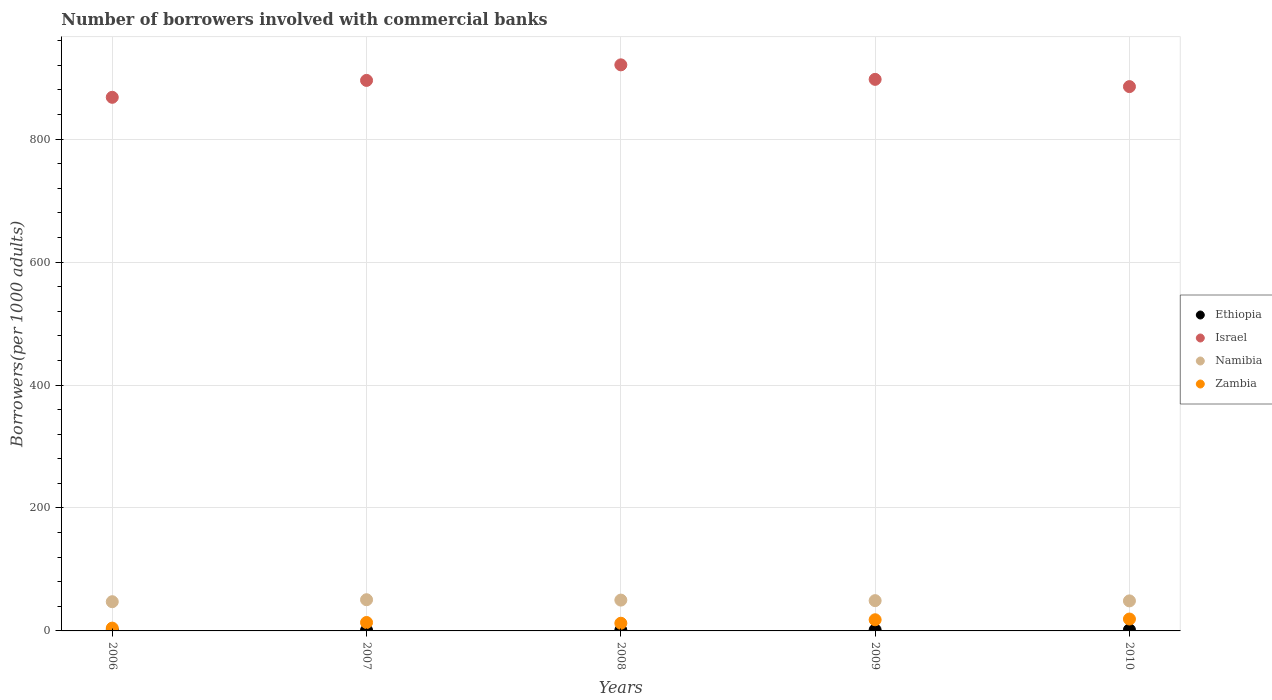How many different coloured dotlines are there?
Offer a very short reply. 4. Is the number of dotlines equal to the number of legend labels?
Keep it short and to the point. Yes. What is the number of borrowers involved with commercial banks in Namibia in 2010?
Your response must be concise. 48.85. Across all years, what is the maximum number of borrowers involved with commercial banks in Namibia?
Make the answer very short. 50.74. Across all years, what is the minimum number of borrowers involved with commercial banks in Namibia?
Keep it short and to the point. 47.51. In which year was the number of borrowers involved with commercial banks in Zambia maximum?
Make the answer very short. 2010. In which year was the number of borrowers involved with commercial banks in Namibia minimum?
Ensure brevity in your answer.  2006. What is the total number of borrowers involved with commercial banks in Namibia in the graph?
Keep it short and to the point. 246.49. What is the difference between the number of borrowers involved with commercial banks in Zambia in 2007 and that in 2010?
Make the answer very short. -5.62. What is the difference between the number of borrowers involved with commercial banks in Israel in 2006 and the number of borrowers involved with commercial banks in Ethiopia in 2007?
Give a very brief answer. 866.91. What is the average number of borrowers involved with commercial banks in Zambia per year?
Offer a very short reply. 13.64. In the year 2009, what is the difference between the number of borrowers involved with commercial banks in Namibia and number of borrowers involved with commercial banks in Ethiopia?
Provide a short and direct response. 47.6. What is the ratio of the number of borrowers involved with commercial banks in Zambia in 2007 to that in 2010?
Your response must be concise. 0.71. Is the number of borrowers involved with commercial banks in Israel in 2006 less than that in 2010?
Give a very brief answer. Yes. What is the difference between the highest and the second highest number of borrowers involved with commercial banks in Israel?
Provide a short and direct response. 23.61. What is the difference between the highest and the lowest number of borrowers involved with commercial banks in Ethiopia?
Ensure brevity in your answer.  0.73. In how many years, is the number of borrowers involved with commercial banks in Israel greater than the average number of borrowers involved with commercial banks in Israel taken over all years?
Offer a very short reply. 3. Is the sum of the number of borrowers involved with commercial banks in Namibia in 2007 and 2010 greater than the maximum number of borrowers involved with commercial banks in Zambia across all years?
Offer a very short reply. Yes. Is it the case that in every year, the sum of the number of borrowers involved with commercial banks in Israel and number of borrowers involved with commercial banks in Namibia  is greater than the sum of number of borrowers involved with commercial banks in Zambia and number of borrowers involved with commercial banks in Ethiopia?
Your answer should be compact. Yes. Is it the case that in every year, the sum of the number of borrowers involved with commercial banks in Zambia and number of borrowers involved with commercial banks in Israel  is greater than the number of borrowers involved with commercial banks in Ethiopia?
Your answer should be very brief. Yes. Is the number of borrowers involved with commercial banks in Israel strictly greater than the number of borrowers involved with commercial banks in Namibia over the years?
Give a very brief answer. Yes. Is the number of borrowers involved with commercial banks in Namibia strictly less than the number of borrowers involved with commercial banks in Israel over the years?
Your response must be concise. Yes. How many dotlines are there?
Give a very brief answer. 4. How many years are there in the graph?
Provide a succinct answer. 5. What is the difference between two consecutive major ticks on the Y-axis?
Offer a terse response. 200. Are the values on the major ticks of Y-axis written in scientific E-notation?
Provide a short and direct response. No. Where does the legend appear in the graph?
Keep it short and to the point. Center right. What is the title of the graph?
Provide a succinct answer. Number of borrowers involved with commercial banks. What is the label or title of the X-axis?
Give a very brief answer. Years. What is the label or title of the Y-axis?
Offer a terse response. Borrowers(per 1000 adults). What is the Borrowers(per 1000 adults) in Ethiopia in 2006?
Make the answer very short. 1.21. What is the Borrowers(per 1000 adults) in Israel in 2006?
Your answer should be very brief. 867.97. What is the Borrowers(per 1000 adults) in Namibia in 2006?
Offer a very short reply. 47.51. What is the Borrowers(per 1000 adults) of Zambia in 2006?
Give a very brief answer. 4.56. What is the Borrowers(per 1000 adults) of Ethiopia in 2007?
Your answer should be very brief. 1.05. What is the Borrowers(per 1000 adults) in Israel in 2007?
Keep it short and to the point. 895.46. What is the Borrowers(per 1000 adults) in Namibia in 2007?
Your answer should be compact. 50.74. What is the Borrowers(per 1000 adults) in Zambia in 2007?
Offer a very short reply. 13.71. What is the Borrowers(per 1000 adults) in Ethiopia in 2008?
Make the answer very short. 1.18. What is the Borrowers(per 1000 adults) of Israel in 2008?
Make the answer very short. 920.77. What is the Borrowers(per 1000 adults) of Namibia in 2008?
Keep it short and to the point. 50.14. What is the Borrowers(per 1000 adults) in Zambia in 2008?
Your answer should be very brief. 12.48. What is the Borrowers(per 1000 adults) in Ethiopia in 2009?
Provide a succinct answer. 1.65. What is the Borrowers(per 1000 adults) of Israel in 2009?
Your response must be concise. 897.16. What is the Borrowers(per 1000 adults) in Namibia in 2009?
Offer a very short reply. 49.25. What is the Borrowers(per 1000 adults) in Zambia in 2009?
Your response must be concise. 18.15. What is the Borrowers(per 1000 adults) of Ethiopia in 2010?
Make the answer very short. 1.78. What is the Borrowers(per 1000 adults) of Israel in 2010?
Provide a short and direct response. 885.37. What is the Borrowers(per 1000 adults) of Namibia in 2010?
Your answer should be very brief. 48.85. What is the Borrowers(per 1000 adults) of Zambia in 2010?
Provide a succinct answer. 19.32. Across all years, what is the maximum Borrowers(per 1000 adults) in Ethiopia?
Ensure brevity in your answer.  1.78. Across all years, what is the maximum Borrowers(per 1000 adults) in Israel?
Your answer should be compact. 920.77. Across all years, what is the maximum Borrowers(per 1000 adults) of Namibia?
Provide a succinct answer. 50.74. Across all years, what is the maximum Borrowers(per 1000 adults) in Zambia?
Give a very brief answer. 19.32. Across all years, what is the minimum Borrowers(per 1000 adults) in Ethiopia?
Offer a terse response. 1.05. Across all years, what is the minimum Borrowers(per 1000 adults) in Israel?
Your answer should be compact. 867.97. Across all years, what is the minimum Borrowers(per 1000 adults) in Namibia?
Keep it short and to the point. 47.51. Across all years, what is the minimum Borrowers(per 1000 adults) of Zambia?
Provide a short and direct response. 4.56. What is the total Borrowers(per 1000 adults) of Ethiopia in the graph?
Offer a terse response. 6.88. What is the total Borrowers(per 1000 adults) of Israel in the graph?
Your response must be concise. 4466.73. What is the total Borrowers(per 1000 adults) in Namibia in the graph?
Keep it short and to the point. 246.49. What is the total Borrowers(per 1000 adults) in Zambia in the graph?
Ensure brevity in your answer.  68.22. What is the difference between the Borrowers(per 1000 adults) in Ethiopia in 2006 and that in 2007?
Provide a succinct answer. 0.15. What is the difference between the Borrowers(per 1000 adults) in Israel in 2006 and that in 2007?
Give a very brief answer. -27.5. What is the difference between the Borrowers(per 1000 adults) of Namibia in 2006 and that in 2007?
Your answer should be very brief. -3.23. What is the difference between the Borrowers(per 1000 adults) in Zambia in 2006 and that in 2007?
Your answer should be very brief. -9.14. What is the difference between the Borrowers(per 1000 adults) of Ethiopia in 2006 and that in 2008?
Your answer should be compact. 0.02. What is the difference between the Borrowers(per 1000 adults) of Israel in 2006 and that in 2008?
Provide a succinct answer. -52.8. What is the difference between the Borrowers(per 1000 adults) of Namibia in 2006 and that in 2008?
Your answer should be compact. -2.63. What is the difference between the Borrowers(per 1000 adults) in Zambia in 2006 and that in 2008?
Offer a very short reply. -7.92. What is the difference between the Borrowers(per 1000 adults) in Ethiopia in 2006 and that in 2009?
Keep it short and to the point. -0.45. What is the difference between the Borrowers(per 1000 adults) in Israel in 2006 and that in 2009?
Keep it short and to the point. -29.19. What is the difference between the Borrowers(per 1000 adults) in Namibia in 2006 and that in 2009?
Offer a very short reply. -1.74. What is the difference between the Borrowers(per 1000 adults) in Zambia in 2006 and that in 2009?
Provide a short and direct response. -13.59. What is the difference between the Borrowers(per 1000 adults) of Ethiopia in 2006 and that in 2010?
Give a very brief answer. -0.58. What is the difference between the Borrowers(per 1000 adults) of Israel in 2006 and that in 2010?
Keep it short and to the point. -17.4. What is the difference between the Borrowers(per 1000 adults) of Namibia in 2006 and that in 2010?
Keep it short and to the point. -1.34. What is the difference between the Borrowers(per 1000 adults) of Zambia in 2006 and that in 2010?
Your answer should be very brief. -14.76. What is the difference between the Borrowers(per 1000 adults) in Ethiopia in 2007 and that in 2008?
Keep it short and to the point. -0.13. What is the difference between the Borrowers(per 1000 adults) in Israel in 2007 and that in 2008?
Make the answer very short. -25.3. What is the difference between the Borrowers(per 1000 adults) of Namibia in 2007 and that in 2008?
Your answer should be very brief. 0.6. What is the difference between the Borrowers(per 1000 adults) in Zambia in 2007 and that in 2008?
Offer a terse response. 1.22. What is the difference between the Borrowers(per 1000 adults) in Ethiopia in 2007 and that in 2009?
Give a very brief answer. -0.6. What is the difference between the Borrowers(per 1000 adults) of Israel in 2007 and that in 2009?
Offer a terse response. -1.7. What is the difference between the Borrowers(per 1000 adults) in Namibia in 2007 and that in 2009?
Your response must be concise. 1.49. What is the difference between the Borrowers(per 1000 adults) of Zambia in 2007 and that in 2009?
Your response must be concise. -4.45. What is the difference between the Borrowers(per 1000 adults) in Ethiopia in 2007 and that in 2010?
Your response must be concise. -0.73. What is the difference between the Borrowers(per 1000 adults) in Israel in 2007 and that in 2010?
Offer a terse response. 10.09. What is the difference between the Borrowers(per 1000 adults) of Namibia in 2007 and that in 2010?
Offer a terse response. 1.89. What is the difference between the Borrowers(per 1000 adults) in Zambia in 2007 and that in 2010?
Keep it short and to the point. -5.62. What is the difference between the Borrowers(per 1000 adults) of Ethiopia in 2008 and that in 2009?
Your answer should be compact. -0.47. What is the difference between the Borrowers(per 1000 adults) of Israel in 2008 and that in 2009?
Offer a very short reply. 23.61. What is the difference between the Borrowers(per 1000 adults) in Namibia in 2008 and that in 2009?
Keep it short and to the point. 0.89. What is the difference between the Borrowers(per 1000 adults) in Zambia in 2008 and that in 2009?
Offer a terse response. -5.67. What is the difference between the Borrowers(per 1000 adults) of Ethiopia in 2008 and that in 2010?
Ensure brevity in your answer.  -0.6. What is the difference between the Borrowers(per 1000 adults) of Israel in 2008 and that in 2010?
Make the answer very short. 35.4. What is the difference between the Borrowers(per 1000 adults) in Namibia in 2008 and that in 2010?
Make the answer very short. 1.29. What is the difference between the Borrowers(per 1000 adults) in Zambia in 2008 and that in 2010?
Your answer should be compact. -6.84. What is the difference between the Borrowers(per 1000 adults) in Ethiopia in 2009 and that in 2010?
Your answer should be very brief. -0.13. What is the difference between the Borrowers(per 1000 adults) of Israel in 2009 and that in 2010?
Give a very brief answer. 11.79. What is the difference between the Borrowers(per 1000 adults) of Namibia in 2009 and that in 2010?
Offer a terse response. 0.4. What is the difference between the Borrowers(per 1000 adults) in Zambia in 2009 and that in 2010?
Offer a terse response. -1.17. What is the difference between the Borrowers(per 1000 adults) of Ethiopia in 2006 and the Borrowers(per 1000 adults) of Israel in 2007?
Give a very brief answer. -894.26. What is the difference between the Borrowers(per 1000 adults) in Ethiopia in 2006 and the Borrowers(per 1000 adults) in Namibia in 2007?
Keep it short and to the point. -49.53. What is the difference between the Borrowers(per 1000 adults) in Ethiopia in 2006 and the Borrowers(per 1000 adults) in Zambia in 2007?
Your response must be concise. -12.5. What is the difference between the Borrowers(per 1000 adults) in Israel in 2006 and the Borrowers(per 1000 adults) in Namibia in 2007?
Your answer should be very brief. 817.23. What is the difference between the Borrowers(per 1000 adults) in Israel in 2006 and the Borrowers(per 1000 adults) in Zambia in 2007?
Provide a short and direct response. 854.26. What is the difference between the Borrowers(per 1000 adults) of Namibia in 2006 and the Borrowers(per 1000 adults) of Zambia in 2007?
Provide a succinct answer. 33.8. What is the difference between the Borrowers(per 1000 adults) in Ethiopia in 2006 and the Borrowers(per 1000 adults) in Israel in 2008?
Give a very brief answer. -919.56. What is the difference between the Borrowers(per 1000 adults) in Ethiopia in 2006 and the Borrowers(per 1000 adults) in Namibia in 2008?
Offer a very short reply. -48.93. What is the difference between the Borrowers(per 1000 adults) of Ethiopia in 2006 and the Borrowers(per 1000 adults) of Zambia in 2008?
Give a very brief answer. -11.28. What is the difference between the Borrowers(per 1000 adults) of Israel in 2006 and the Borrowers(per 1000 adults) of Namibia in 2008?
Ensure brevity in your answer.  817.83. What is the difference between the Borrowers(per 1000 adults) of Israel in 2006 and the Borrowers(per 1000 adults) of Zambia in 2008?
Your response must be concise. 855.48. What is the difference between the Borrowers(per 1000 adults) in Namibia in 2006 and the Borrowers(per 1000 adults) in Zambia in 2008?
Offer a terse response. 35.03. What is the difference between the Borrowers(per 1000 adults) of Ethiopia in 2006 and the Borrowers(per 1000 adults) of Israel in 2009?
Provide a short and direct response. -895.95. What is the difference between the Borrowers(per 1000 adults) of Ethiopia in 2006 and the Borrowers(per 1000 adults) of Namibia in 2009?
Your answer should be very brief. -48.04. What is the difference between the Borrowers(per 1000 adults) of Ethiopia in 2006 and the Borrowers(per 1000 adults) of Zambia in 2009?
Provide a succinct answer. -16.95. What is the difference between the Borrowers(per 1000 adults) in Israel in 2006 and the Borrowers(per 1000 adults) in Namibia in 2009?
Give a very brief answer. 818.72. What is the difference between the Borrowers(per 1000 adults) of Israel in 2006 and the Borrowers(per 1000 adults) of Zambia in 2009?
Your answer should be very brief. 849.81. What is the difference between the Borrowers(per 1000 adults) in Namibia in 2006 and the Borrowers(per 1000 adults) in Zambia in 2009?
Your response must be concise. 29.36. What is the difference between the Borrowers(per 1000 adults) in Ethiopia in 2006 and the Borrowers(per 1000 adults) in Israel in 2010?
Keep it short and to the point. -884.16. What is the difference between the Borrowers(per 1000 adults) in Ethiopia in 2006 and the Borrowers(per 1000 adults) in Namibia in 2010?
Offer a terse response. -47.64. What is the difference between the Borrowers(per 1000 adults) in Ethiopia in 2006 and the Borrowers(per 1000 adults) in Zambia in 2010?
Keep it short and to the point. -18.12. What is the difference between the Borrowers(per 1000 adults) in Israel in 2006 and the Borrowers(per 1000 adults) in Namibia in 2010?
Give a very brief answer. 819.12. What is the difference between the Borrowers(per 1000 adults) in Israel in 2006 and the Borrowers(per 1000 adults) in Zambia in 2010?
Provide a short and direct response. 848.64. What is the difference between the Borrowers(per 1000 adults) of Namibia in 2006 and the Borrowers(per 1000 adults) of Zambia in 2010?
Ensure brevity in your answer.  28.19. What is the difference between the Borrowers(per 1000 adults) of Ethiopia in 2007 and the Borrowers(per 1000 adults) of Israel in 2008?
Keep it short and to the point. -919.72. What is the difference between the Borrowers(per 1000 adults) of Ethiopia in 2007 and the Borrowers(per 1000 adults) of Namibia in 2008?
Provide a succinct answer. -49.09. What is the difference between the Borrowers(per 1000 adults) in Ethiopia in 2007 and the Borrowers(per 1000 adults) in Zambia in 2008?
Provide a succinct answer. -11.43. What is the difference between the Borrowers(per 1000 adults) in Israel in 2007 and the Borrowers(per 1000 adults) in Namibia in 2008?
Offer a very short reply. 845.32. What is the difference between the Borrowers(per 1000 adults) of Israel in 2007 and the Borrowers(per 1000 adults) of Zambia in 2008?
Give a very brief answer. 882.98. What is the difference between the Borrowers(per 1000 adults) in Namibia in 2007 and the Borrowers(per 1000 adults) in Zambia in 2008?
Your answer should be very brief. 38.26. What is the difference between the Borrowers(per 1000 adults) in Ethiopia in 2007 and the Borrowers(per 1000 adults) in Israel in 2009?
Your answer should be very brief. -896.11. What is the difference between the Borrowers(per 1000 adults) in Ethiopia in 2007 and the Borrowers(per 1000 adults) in Namibia in 2009?
Your answer should be very brief. -48.2. What is the difference between the Borrowers(per 1000 adults) in Ethiopia in 2007 and the Borrowers(per 1000 adults) in Zambia in 2009?
Make the answer very short. -17.1. What is the difference between the Borrowers(per 1000 adults) in Israel in 2007 and the Borrowers(per 1000 adults) in Namibia in 2009?
Offer a very short reply. 846.21. What is the difference between the Borrowers(per 1000 adults) in Israel in 2007 and the Borrowers(per 1000 adults) in Zambia in 2009?
Offer a very short reply. 877.31. What is the difference between the Borrowers(per 1000 adults) in Namibia in 2007 and the Borrowers(per 1000 adults) in Zambia in 2009?
Your answer should be compact. 32.59. What is the difference between the Borrowers(per 1000 adults) of Ethiopia in 2007 and the Borrowers(per 1000 adults) of Israel in 2010?
Provide a succinct answer. -884.32. What is the difference between the Borrowers(per 1000 adults) of Ethiopia in 2007 and the Borrowers(per 1000 adults) of Namibia in 2010?
Ensure brevity in your answer.  -47.79. What is the difference between the Borrowers(per 1000 adults) of Ethiopia in 2007 and the Borrowers(per 1000 adults) of Zambia in 2010?
Provide a succinct answer. -18.27. What is the difference between the Borrowers(per 1000 adults) of Israel in 2007 and the Borrowers(per 1000 adults) of Namibia in 2010?
Ensure brevity in your answer.  846.62. What is the difference between the Borrowers(per 1000 adults) of Israel in 2007 and the Borrowers(per 1000 adults) of Zambia in 2010?
Your response must be concise. 876.14. What is the difference between the Borrowers(per 1000 adults) in Namibia in 2007 and the Borrowers(per 1000 adults) in Zambia in 2010?
Your answer should be very brief. 31.42. What is the difference between the Borrowers(per 1000 adults) in Ethiopia in 2008 and the Borrowers(per 1000 adults) in Israel in 2009?
Your answer should be very brief. -895.98. What is the difference between the Borrowers(per 1000 adults) of Ethiopia in 2008 and the Borrowers(per 1000 adults) of Namibia in 2009?
Ensure brevity in your answer.  -48.07. What is the difference between the Borrowers(per 1000 adults) of Ethiopia in 2008 and the Borrowers(per 1000 adults) of Zambia in 2009?
Keep it short and to the point. -16.97. What is the difference between the Borrowers(per 1000 adults) of Israel in 2008 and the Borrowers(per 1000 adults) of Namibia in 2009?
Make the answer very short. 871.52. What is the difference between the Borrowers(per 1000 adults) in Israel in 2008 and the Borrowers(per 1000 adults) in Zambia in 2009?
Your answer should be compact. 902.62. What is the difference between the Borrowers(per 1000 adults) in Namibia in 2008 and the Borrowers(per 1000 adults) in Zambia in 2009?
Your response must be concise. 31.99. What is the difference between the Borrowers(per 1000 adults) in Ethiopia in 2008 and the Borrowers(per 1000 adults) in Israel in 2010?
Make the answer very short. -884.19. What is the difference between the Borrowers(per 1000 adults) in Ethiopia in 2008 and the Borrowers(per 1000 adults) in Namibia in 2010?
Your response must be concise. -47.67. What is the difference between the Borrowers(per 1000 adults) of Ethiopia in 2008 and the Borrowers(per 1000 adults) of Zambia in 2010?
Offer a terse response. -18.14. What is the difference between the Borrowers(per 1000 adults) of Israel in 2008 and the Borrowers(per 1000 adults) of Namibia in 2010?
Provide a succinct answer. 871.92. What is the difference between the Borrowers(per 1000 adults) in Israel in 2008 and the Borrowers(per 1000 adults) in Zambia in 2010?
Provide a succinct answer. 901.45. What is the difference between the Borrowers(per 1000 adults) of Namibia in 2008 and the Borrowers(per 1000 adults) of Zambia in 2010?
Provide a short and direct response. 30.82. What is the difference between the Borrowers(per 1000 adults) in Ethiopia in 2009 and the Borrowers(per 1000 adults) in Israel in 2010?
Ensure brevity in your answer.  -883.72. What is the difference between the Borrowers(per 1000 adults) in Ethiopia in 2009 and the Borrowers(per 1000 adults) in Namibia in 2010?
Your answer should be compact. -47.2. What is the difference between the Borrowers(per 1000 adults) in Ethiopia in 2009 and the Borrowers(per 1000 adults) in Zambia in 2010?
Your response must be concise. -17.67. What is the difference between the Borrowers(per 1000 adults) of Israel in 2009 and the Borrowers(per 1000 adults) of Namibia in 2010?
Ensure brevity in your answer.  848.31. What is the difference between the Borrowers(per 1000 adults) in Israel in 2009 and the Borrowers(per 1000 adults) in Zambia in 2010?
Your answer should be compact. 877.84. What is the difference between the Borrowers(per 1000 adults) of Namibia in 2009 and the Borrowers(per 1000 adults) of Zambia in 2010?
Offer a terse response. 29.93. What is the average Borrowers(per 1000 adults) of Ethiopia per year?
Ensure brevity in your answer.  1.38. What is the average Borrowers(per 1000 adults) in Israel per year?
Provide a succinct answer. 893.35. What is the average Borrowers(per 1000 adults) of Namibia per year?
Offer a terse response. 49.3. What is the average Borrowers(per 1000 adults) of Zambia per year?
Provide a short and direct response. 13.64. In the year 2006, what is the difference between the Borrowers(per 1000 adults) of Ethiopia and Borrowers(per 1000 adults) of Israel?
Your response must be concise. -866.76. In the year 2006, what is the difference between the Borrowers(per 1000 adults) of Ethiopia and Borrowers(per 1000 adults) of Namibia?
Make the answer very short. -46.3. In the year 2006, what is the difference between the Borrowers(per 1000 adults) in Ethiopia and Borrowers(per 1000 adults) in Zambia?
Ensure brevity in your answer.  -3.36. In the year 2006, what is the difference between the Borrowers(per 1000 adults) in Israel and Borrowers(per 1000 adults) in Namibia?
Provide a short and direct response. 820.46. In the year 2006, what is the difference between the Borrowers(per 1000 adults) of Israel and Borrowers(per 1000 adults) of Zambia?
Provide a short and direct response. 863.4. In the year 2006, what is the difference between the Borrowers(per 1000 adults) of Namibia and Borrowers(per 1000 adults) of Zambia?
Offer a terse response. 42.95. In the year 2007, what is the difference between the Borrowers(per 1000 adults) in Ethiopia and Borrowers(per 1000 adults) in Israel?
Your answer should be very brief. -894.41. In the year 2007, what is the difference between the Borrowers(per 1000 adults) in Ethiopia and Borrowers(per 1000 adults) in Namibia?
Offer a terse response. -49.69. In the year 2007, what is the difference between the Borrowers(per 1000 adults) in Ethiopia and Borrowers(per 1000 adults) in Zambia?
Keep it short and to the point. -12.65. In the year 2007, what is the difference between the Borrowers(per 1000 adults) of Israel and Borrowers(per 1000 adults) of Namibia?
Your response must be concise. 844.73. In the year 2007, what is the difference between the Borrowers(per 1000 adults) of Israel and Borrowers(per 1000 adults) of Zambia?
Ensure brevity in your answer.  881.76. In the year 2007, what is the difference between the Borrowers(per 1000 adults) of Namibia and Borrowers(per 1000 adults) of Zambia?
Offer a terse response. 37.03. In the year 2008, what is the difference between the Borrowers(per 1000 adults) in Ethiopia and Borrowers(per 1000 adults) in Israel?
Your answer should be compact. -919.59. In the year 2008, what is the difference between the Borrowers(per 1000 adults) in Ethiopia and Borrowers(per 1000 adults) in Namibia?
Make the answer very short. -48.96. In the year 2008, what is the difference between the Borrowers(per 1000 adults) in Ethiopia and Borrowers(per 1000 adults) in Zambia?
Give a very brief answer. -11.3. In the year 2008, what is the difference between the Borrowers(per 1000 adults) in Israel and Borrowers(per 1000 adults) in Namibia?
Provide a short and direct response. 870.63. In the year 2008, what is the difference between the Borrowers(per 1000 adults) of Israel and Borrowers(per 1000 adults) of Zambia?
Offer a terse response. 908.29. In the year 2008, what is the difference between the Borrowers(per 1000 adults) in Namibia and Borrowers(per 1000 adults) in Zambia?
Your answer should be compact. 37.66. In the year 2009, what is the difference between the Borrowers(per 1000 adults) of Ethiopia and Borrowers(per 1000 adults) of Israel?
Make the answer very short. -895.51. In the year 2009, what is the difference between the Borrowers(per 1000 adults) of Ethiopia and Borrowers(per 1000 adults) of Namibia?
Your answer should be very brief. -47.6. In the year 2009, what is the difference between the Borrowers(per 1000 adults) of Ethiopia and Borrowers(per 1000 adults) of Zambia?
Make the answer very short. -16.5. In the year 2009, what is the difference between the Borrowers(per 1000 adults) in Israel and Borrowers(per 1000 adults) in Namibia?
Your answer should be very brief. 847.91. In the year 2009, what is the difference between the Borrowers(per 1000 adults) of Israel and Borrowers(per 1000 adults) of Zambia?
Your answer should be compact. 879.01. In the year 2009, what is the difference between the Borrowers(per 1000 adults) in Namibia and Borrowers(per 1000 adults) in Zambia?
Provide a succinct answer. 31.1. In the year 2010, what is the difference between the Borrowers(per 1000 adults) in Ethiopia and Borrowers(per 1000 adults) in Israel?
Provide a short and direct response. -883.59. In the year 2010, what is the difference between the Borrowers(per 1000 adults) in Ethiopia and Borrowers(per 1000 adults) in Namibia?
Provide a succinct answer. -47.06. In the year 2010, what is the difference between the Borrowers(per 1000 adults) of Ethiopia and Borrowers(per 1000 adults) of Zambia?
Make the answer very short. -17.54. In the year 2010, what is the difference between the Borrowers(per 1000 adults) in Israel and Borrowers(per 1000 adults) in Namibia?
Your response must be concise. 836.52. In the year 2010, what is the difference between the Borrowers(per 1000 adults) in Israel and Borrowers(per 1000 adults) in Zambia?
Provide a short and direct response. 866.05. In the year 2010, what is the difference between the Borrowers(per 1000 adults) of Namibia and Borrowers(per 1000 adults) of Zambia?
Keep it short and to the point. 29.53. What is the ratio of the Borrowers(per 1000 adults) in Ethiopia in 2006 to that in 2007?
Make the answer very short. 1.14. What is the ratio of the Borrowers(per 1000 adults) of Israel in 2006 to that in 2007?
Offer a terse response. 0.97. What is the ratio of the Borrowers(per 1000 adults) in Namibia in 2006 to that in 2007?
Your response must be concise. 0.94. What is the ratio of the Borrowers(per 1000 adults) of Zambia in 2006 to that in 2007?
Offer a terse response. 0.33. What is the ratio of the Borrowers(per 1000 adults) of Ethiopia in 2006 to that in 2008?
Your answer should be compact. 1.02. What is the ratio of the Borrowers(per 1000 adults) in Israel in 2006 to that in 2008?
Give a very brief answer. 0.94. What is the ratio of the Borrowers(per 1000 adults) of Namibia in 2006 to that in 2008?
Ensure brevity in your answer.  0.95. What is the ratio of the Borrowers(per 1000 adults) in Zambia in 2006 to that in 2008?
Your answer should be very brief. 0.37. What is the ratio of the Borrowers(per 1000 adults) in Ethiopia in 2006 to that in 2009?
Offer a very short reply. 0.73. What is the ratio of the Borrowers(per 1000 adults) in Israel in 2006 to that in 2009?
Make the answer very short. 0.97. What is the ratio of the Borrowers(per 1000 adults) of Namibia in 2006 to that in 2009?
Your answer should be very brief. 0.96. What is the ratio of the Borrowers(per 1000 adults) of Zambia in 2006 to that in 2009?
Your response must be concise. 0.25. What is the ratio of the Borrowers(per 1000 adults) of Ethiopia in 2006 to that in 2010?
Give a very brief answer. 0.68. What is the ratio of the Borrowers(per 1000 adults) in Israel in 2006 to that in 2010?
Your response must be concise. 0.98. What is the ratio of the Borrowers(per 1000 adults) in Namibia in 2006 to that in 2010?
Your answer should be very brief. 0.97. What is the ratio of the Borrowers(per 1000 adults) in Zambia in 2006 to that in 2010?
Give a very brief answer. 0.24. What is the ratio of the Borrowers(per 1000 adults) of Ethiopia in 2007 to that in 2008?
Make the answer very short. 0.89. What is the ratio of the Borrowers(per 1000 adults) of Israel in 2007 to that in 2008?
Provide a short and direct response. 0.97. What is the ratio of the Borrowers(per 1000 adults) in Namibia in 2007 to that in 2008?
Provide a succinct answer. 1.01. What is the ratio of the Borrowers(per 1000 adults) of Zambia in 2007 to that in 2008?
Offer a terse response. 1.1. What is the ratio of the Borrowers(per 1000 adults) in Ethiopia in 2007 to that in 2009?
Offer a very short reply. 0.64. What is the ratio of the Borrowers(per 1000 adults) of Israel in 2007 to that in 2009?
Keep it short and to the point. 1. What is the ratio of the Borrowers(per 1000 adults) in Namibia in 2007 to that in 2009?
Ensure brevity in your answer.  1.03. What is the ratio of the Borrowers(per 1000 adults) in Zambia in 2007 to that in 2009?
Provide a short and direct response. 0.76. What is the ratio of the Borrowers(per 1000 adults) of Ethiopia in 2007 to that in 2010?
Ensure brevity in your answer.  0.59. What is the ratio of the Borrowers(per 1000 adults) in Israel in 2007 to that in 2010?
Offer a terse response. 1.01. What is the ratio of the Borrowers(per 1000 adults) in Namibia in 2007 to that in 2010?
Your answer should be compact. 1.04. What is the ratio of the Borrowers(per 1000 adults) in Zambia in 2007 to that in 2010?
Offer a terse response. 0.71. What is the ratio of the Borrowers(per 1000 adults) of Ethiopia in 2008 to that in 2009?
Offer a terse response. 0.72. What is the ratio of the Borrowers(per 1000 adults) in Israel in 2008 to that in 2009?
Offer a very short reply. 1.03. What is the ratio of the Borrowers(per 1000 adults) of Namibia in 2008 to that in 2009?
Your answer should be compact. 1.02. What is the ratio of the Borrowers(per 1000 adults) in Zambia in 2008 to that in 2009?
Make the answer very short. 0.69. What is the ratio of the Borrowers(per 1000 adults) of Ethiopia in 2008 to that in 2010?
Give a very brief answer. 0.66. What is the ratio of the Borrowers(per 1000 adults) in Namibia in 2008 to that in 2010?
Ensure brevity in your answer.  1.03. What is the ratio of the Borrowers(per 1000 adults) in Zambia in 2008 to that in 2010?
Offer a terse response. 0.65. What is the ratio of the Borrowers(per 1000 adults) in Ethiopia in 2009 to that in 2010?
Give a very brief answer. 0.93. What is the ratio of the Borrowers(per 1000 adults) in Israel in 2009 to that in 2010?
Your answer should be compact. 1.01. What is the ratio of the Borrowers(per 1000 adults) in Namibia in 2009 to that in 2010?
Offer a terse response. 1.01. What is the ratio of the Borrowers(per 1000 adults) of Zambia in 2009 to that in 2010?
Provide a succinct answer. 0.94. What is the difference between the highest and the second highest Borrowers(per 1000 adults) of Ethiopia?
Offer a terse response. 0.13. What is the difference between the highest and the second highest Borrowers(per 1000 adults) of Israel?
Ensure brevity in your answer.  23.61. What is the difference between the highest and the second highest Borrowers(per 1000 adults) in Namibia?
Ensure brevity in your answer.  0.6. What is the difference between the highest and the second highest Borrowers(per 1000 adults) in Zambia?
Ensure brevity in your answer.  1.17. What is the difference between the highest and the lowest Borrowers(per 1000 adults) in Ethiopia?
Give a very brief answer. 0.73. What is the difference between the highest and the lowest Borrowers(per 1000 adults) in Israel?
Your response must be concise. 52.8. What is the difference between the highest and the lowest Borrowers(per 1000 adults) in Namibia?
Offer a very short reply. 3.23. What is the difference between the highest and the lowest Borrowers(per 1000 adults) in Zambia?
Provide a succinct answer. 14.76. 